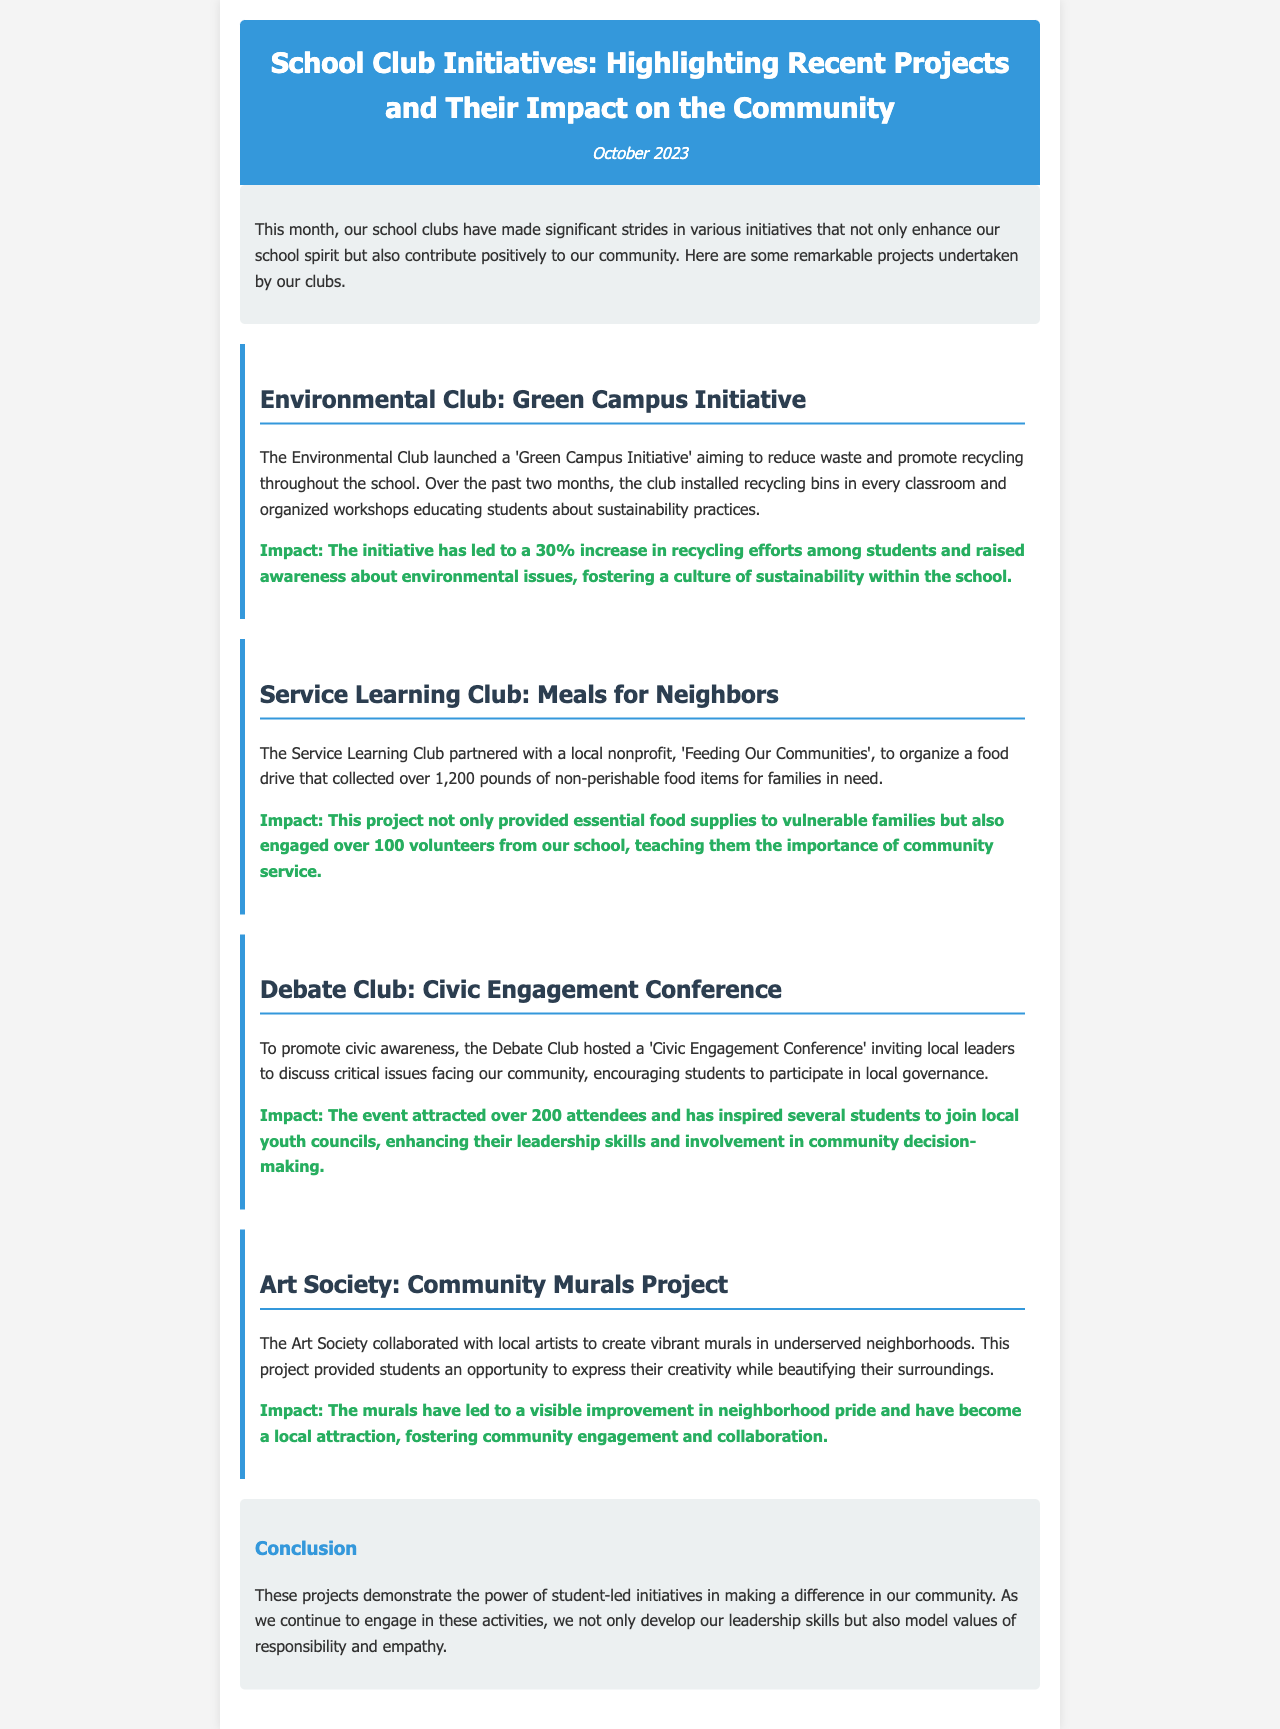What is the title of the newsletter? The title is shown prominently at the top of the document in header format.
Answer: School Club Initiatives: Highlighting Recent Projects and Their Impact on the Community What initiative did the Environmental Club launch? This information is included in the section dedicated to the Environmental Club's project.
Answer: Green Campus Initiative How many pounds of food did the Service Learning Club collect? The document specifies the total amount of food collected during the food drive organized by the Service Learning Club.
Answer: 1,200 pounds How many attendees were attracted to the Civic Engagement Conference? The document notes the number of participants in the debate club's event in its description.
Answer: 200 What was the impact of the Community Murals Project? The impact section for the Art Society describes the outcome of their initiative.
Answer: Visible improvement in neighborhood pride Which club organized workshops about sustainability practices? The document indicates which club was responsible for these educational workshops.
Answer: Environmental Club What was the main theme of the Civic Engagement Conference? The document describes the focus area of the conference organized by the Debate Club.
Answer: Civic awareness How many volunteers were engaged in the Meals for Neighbors project? The number of volunteers involved in the food drive is mentioned in the discussion of the service learning club's project.
Answer: Over 100 volunteers 